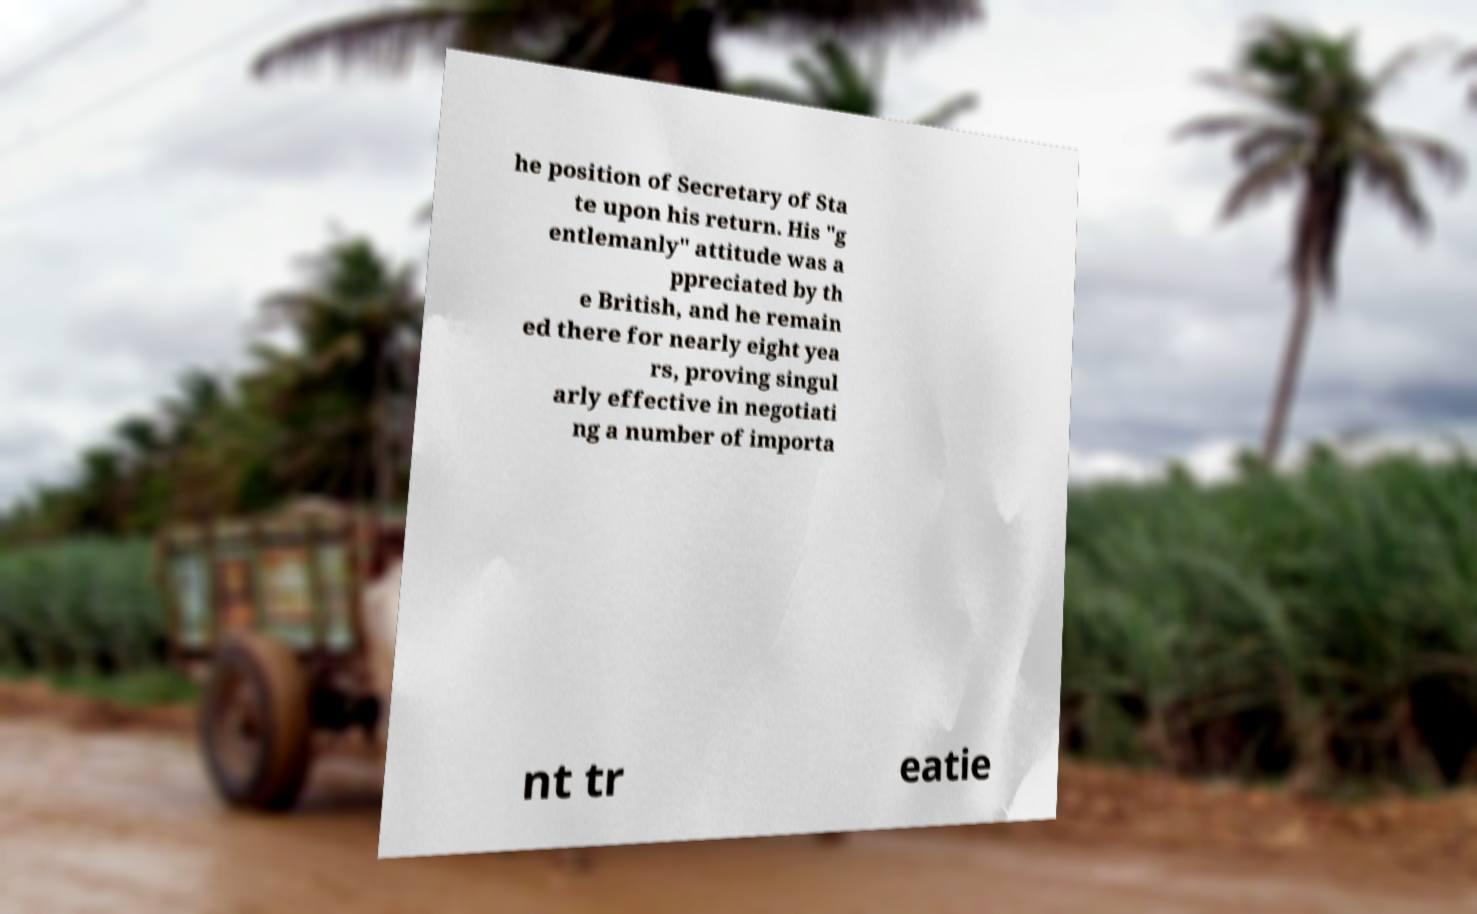For documentation purposes, I need the text within this image transcribed. Could you provide that? he position of Secretary of Sta te upon his return. His "g entlemanly" attitude was a ppreciated by th e British, and he remain ed there for nearly eight yea rs, proving singul arly effective in negotiati ng a number of importa nt tr eatie 